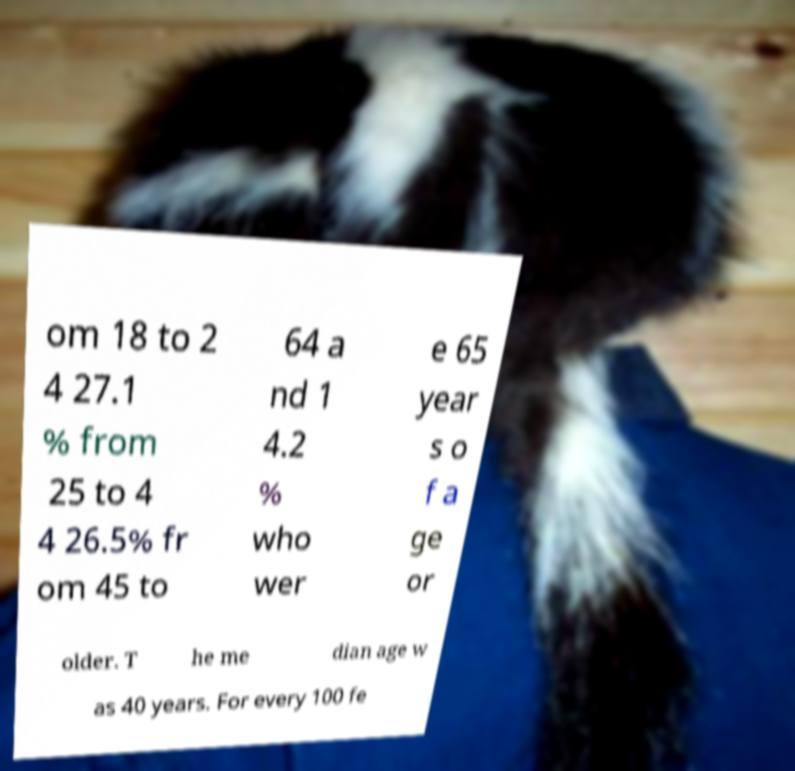Could you assist in decoding the text presented in this image and type it out clearly? om 18 to 2 4 27.1 % from 25 to 4 4 26.5% fr om 45 to 64 a nd 1 4.2 % who wer e 65 year s o f a ge or older. T he me dian age w as 40 years. For every 100 fe 